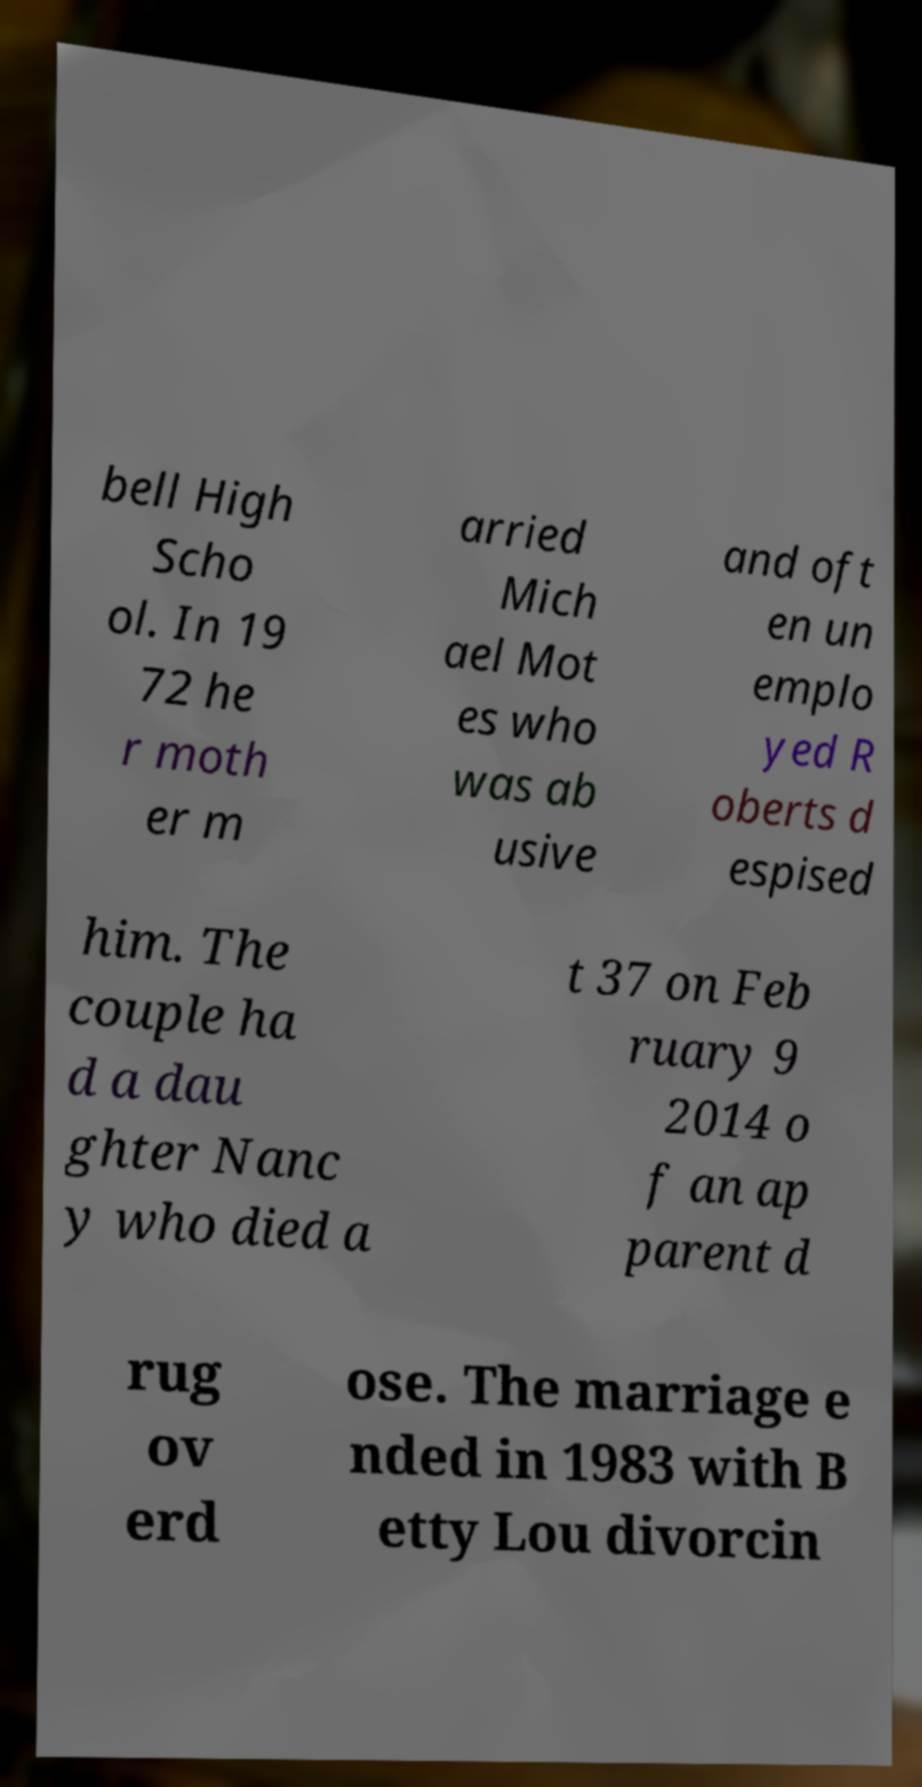Could you assist in decoding the text presented in this image and type it out clearly? bell High Scho ol. In 19 72 he r moth er m arried Mich ael Mot es who was ab usive and oft en un emplo yed R oberts d espised him. The couple ha d a dau ghter Nanc y who died a t 37 on Feb ruary 9 2014 o f an ap parent d rug ov erd ose. The marriage e nded in 1983 with B etty Lou divorcin 